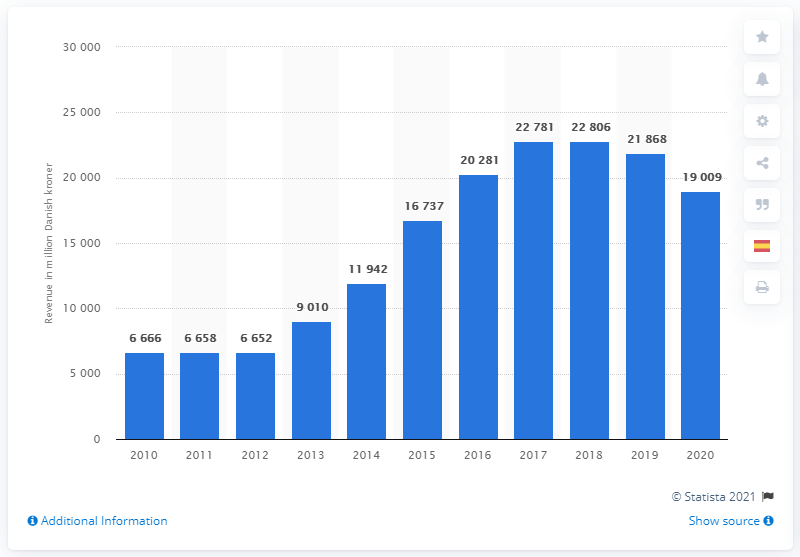Point out several critical features in this image. The total revenue of Pandora A/S in Danish kroner in 2020 was approximately 19,009. 